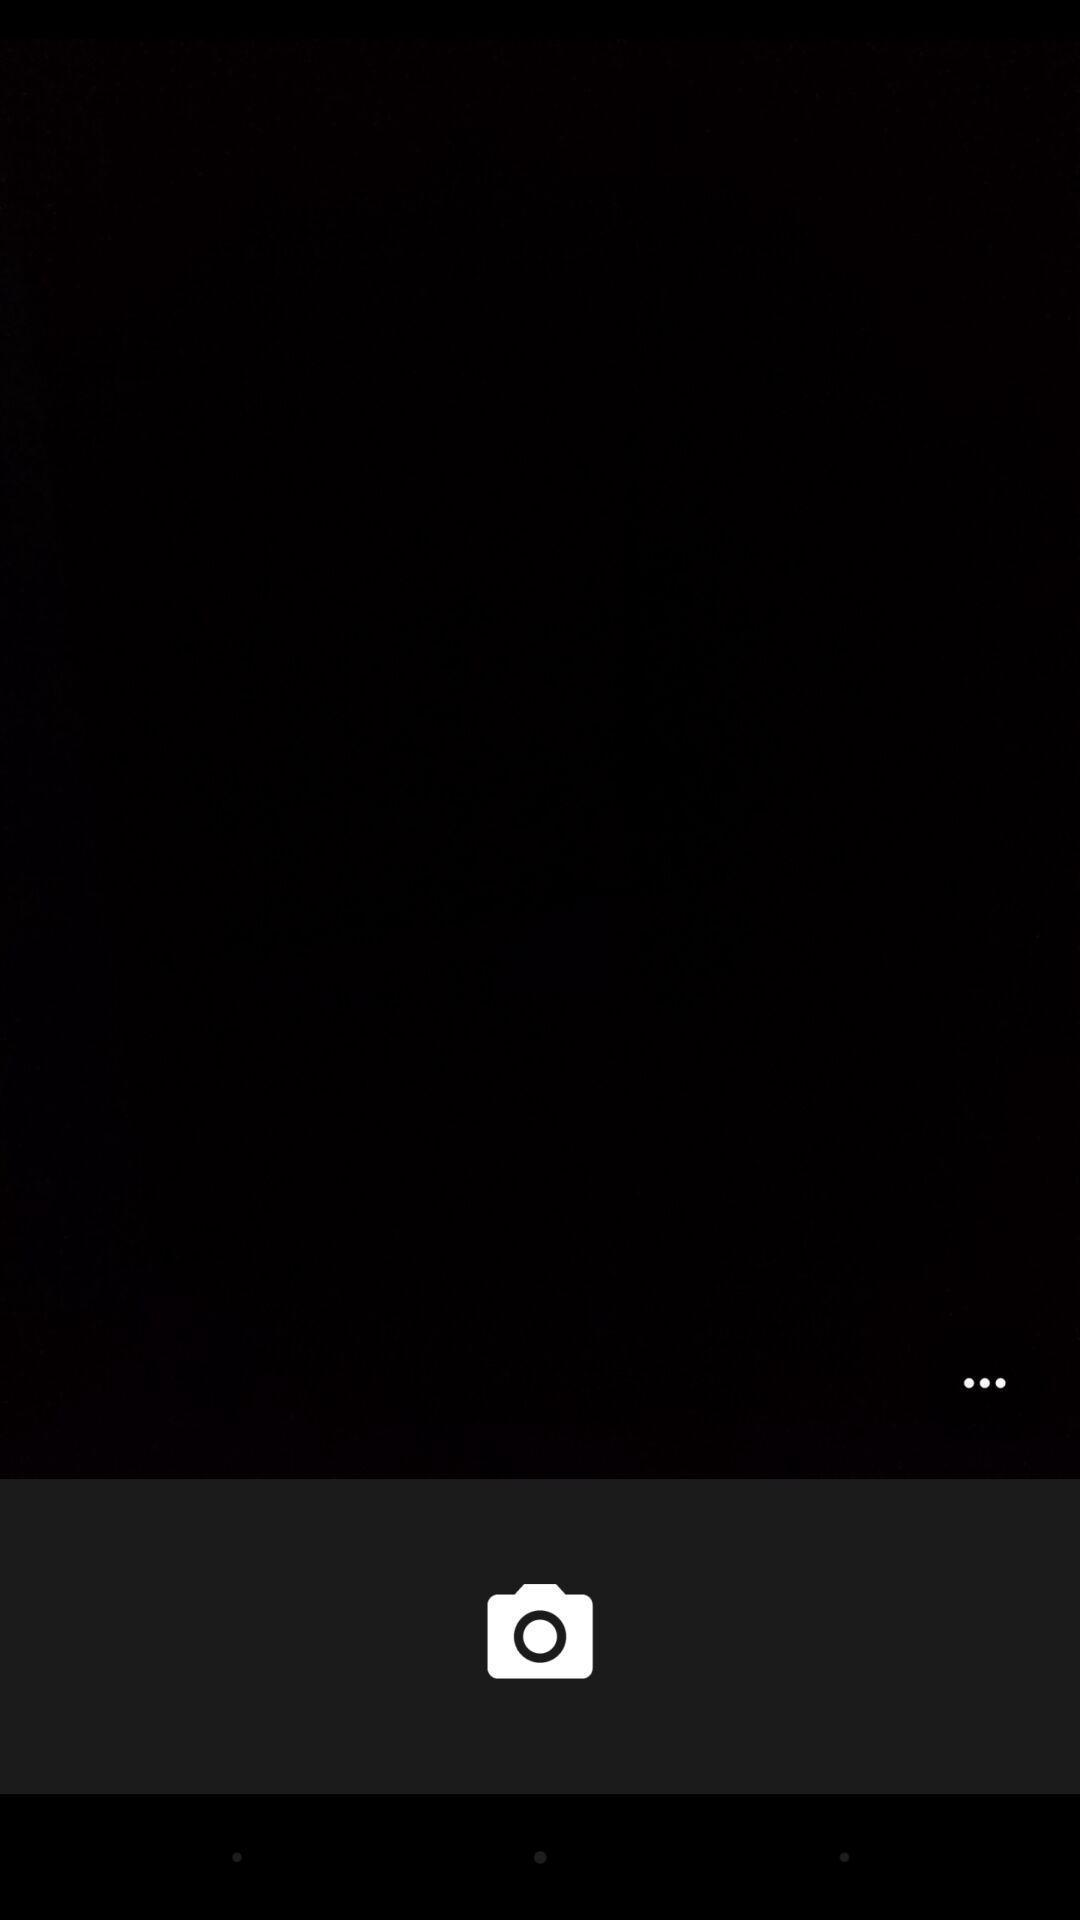What can you discern from this picture? Screen shows blank image with a camera icon. 